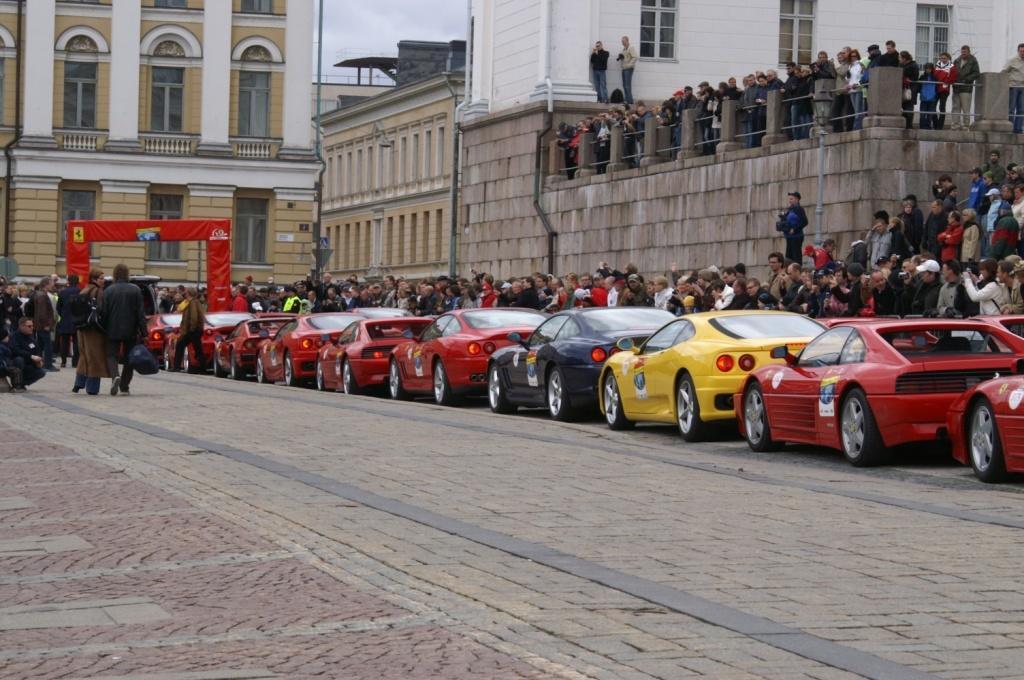How would you summarize this image in a sentence or two? In the background we can see sky, buildings. We can see two men standing here. This man is holding a camera. This is a bag in black color. Here we can see people standing. On the road we can see cars and people. 